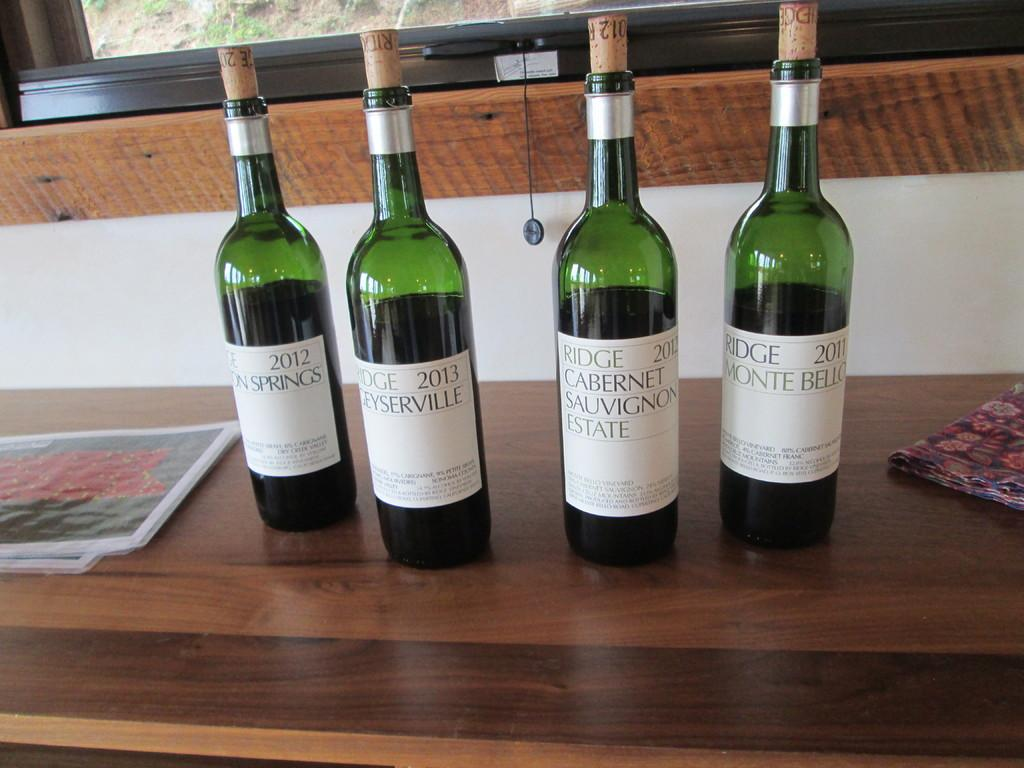<image>
Share a concise interpretation of the image provided. Four bottles of wine, all from different estates and springs. 